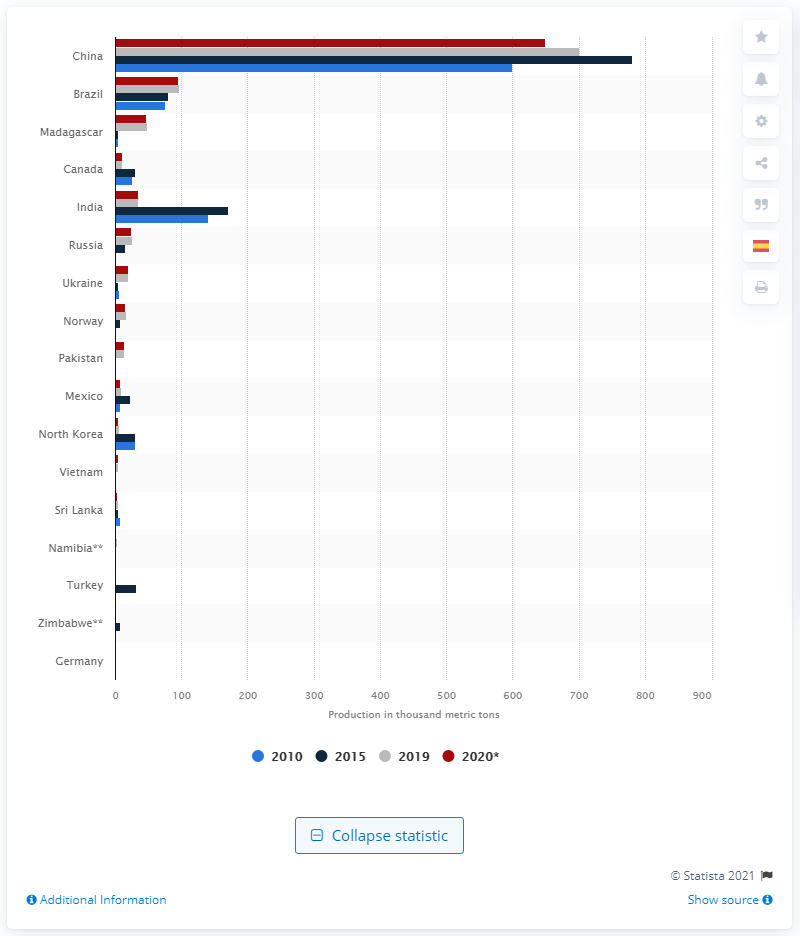Specify some key components in this picture. According to recent statistics, China was the leading producer of graphite in the world in 2020. 